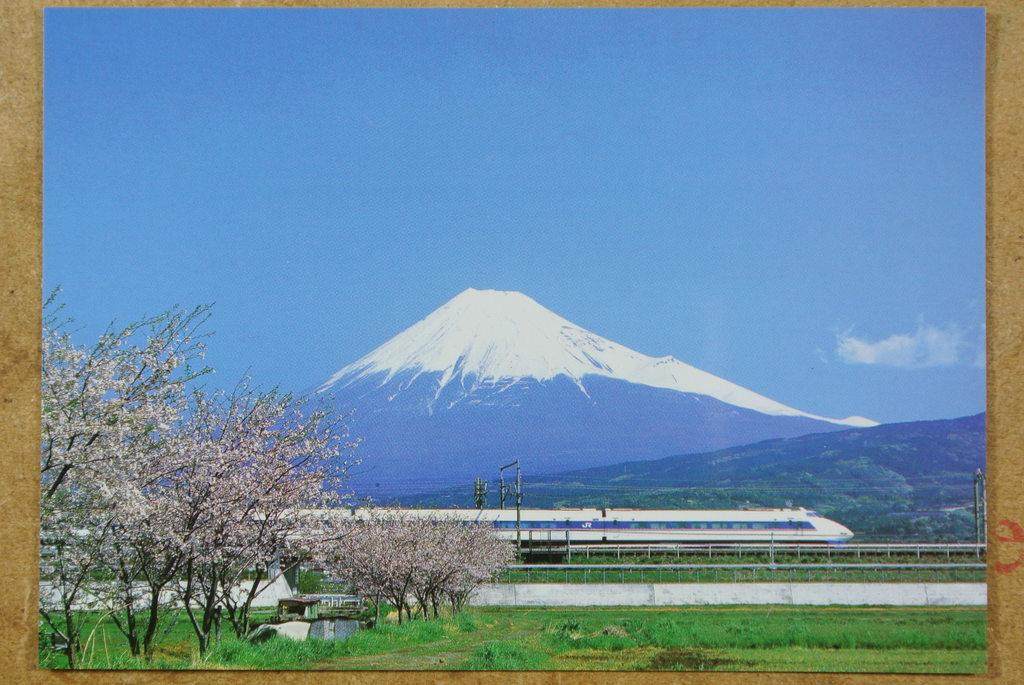What type of vegetation is present in the image? There are many trees and grass in the image. What mode of transportation can be seen in the image? There is a train in the image. What type of infrastructure is present in the image? There are electric poles in the image. What type of path is visible in the image? There is a path in the image. What type of geographical feature is present in the image? There is a mountain in the image. What type of weather condition is depicted in the image? There is snow in the image. What is the color of the sky in the image? The sky is pale blue in the image. What type of loaf is being baked in the oven in the image? There is no oven or loaf present in the image. How does the wind affect the train's movement in the image? There is no wind depicted in the image, and the train's movement is not affected by any wind. 